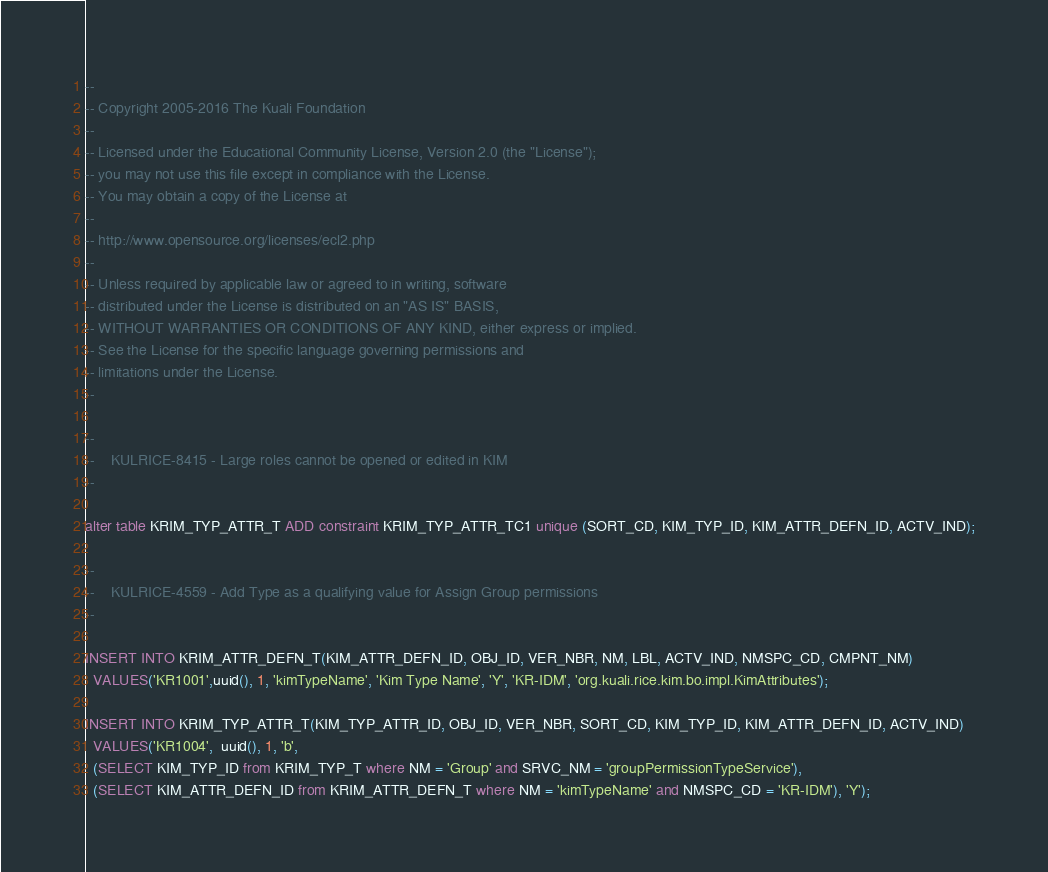<code> <loc_0><loc_0><loc_500><loc_500><_SQL_>--
-- Copyright 2005-2016 The Kuali Foundation
--
-- Licensed under the Educational Community License, Version 2.0 (the "License");
-- you may not use this file except in compliance with the License.
-- You may obtain a copy of the License at
--
-- http://www.opensource.org/licenses/ecl2.php
--
-- Unless required by applicable law or agreed to in writing, software
-- distributed under the License is distributed on an "AS IS" BASIS,
-- WITHOUT WARRANTIES OR CONDITIONS OF ANY KIND, either express or implied.
-- See the License for the specific language governing permissions and
-- limitations under the License.
--

--
--    KULRICE-8415 - Large roles cannot be opened or edited in KIM
--

alter table KRIM_TYP_ATTR_T ADD constraint KRIM_TYP_ATTR_TC1 unique (SORT_CD, KIM_TYP_ID, KIM_ATTR_DEFN_ID, ACTV_IND);

--
--    KULRICE-4559 - Add Type as a qualifying value for Assign Group permissions
--

INSERT INTO KRIM_ATTR_DEFN_T(KIM_ATTR_DEFN_ID, OBJ_ID, VER_NBR, NM, LBL, ACTV_IND, NMSPC_CD, CMPNT_NM)
  VALUES('KR1001',uuid(), 1, 'kimTypeName', 'Kim Type Name', 'Y', 'KR-IDM', 'org.kuali.rice.kim.bo.impl.KimAttributes');

INSERT INTO KRIM_TYP_ATTR_T(KIM_TYP_ATTR_ID, OBJ_ID, VER_NBR, SORT_CD, KIM_TYP_ID, KIM_ATTR_DEFN_ID, ACTV_IND)
  VALUES('KR1004',  uuid(), 1, 'b',
  (SELECT KIM_TYP_ID from KRIM_TYP_T where NM = 'Group' and SRVC_NM = 'groupPermissionTypeService'),
  (SELECT KIM_ATTR_DEFN_ID from KRIM_ATTR_DEFN_T where NM = 'kimTypeName' and NMSPC_CD = 'KR-IDM'), 'Y');</code> 